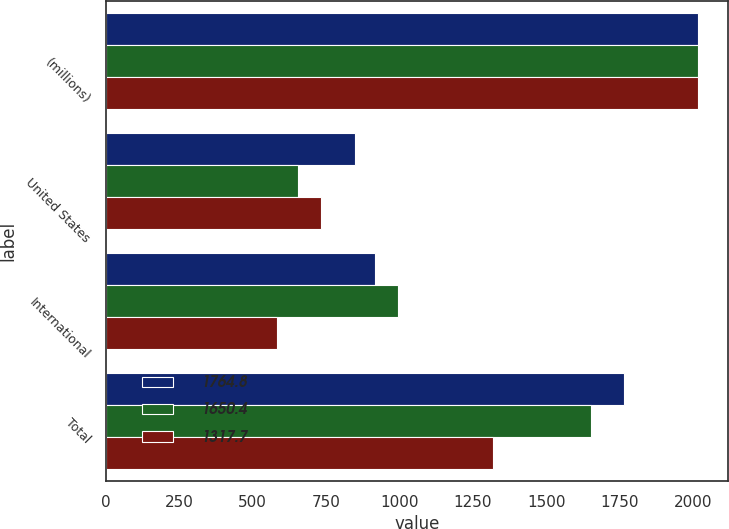Convert chart. <chart><loc_0><loc_0><loc_500><loc_500><stacked_bar_chart><ecel><fcel>(millions)<fcel>United States<fcel>International<fcel>Total<nl><fcel>1764.8<fcel>2017<fcel>848.4<fcel>916.4<fcel>1764.8<nl><fcel>1650.4<fcel>2016<fcel>656.1<fcel>994.3<fcel>1650.4<nl><fcel>1317.7<fcel>2015<fcel>733<fcel>584.7<fcel>1317.7<nl></chart> 